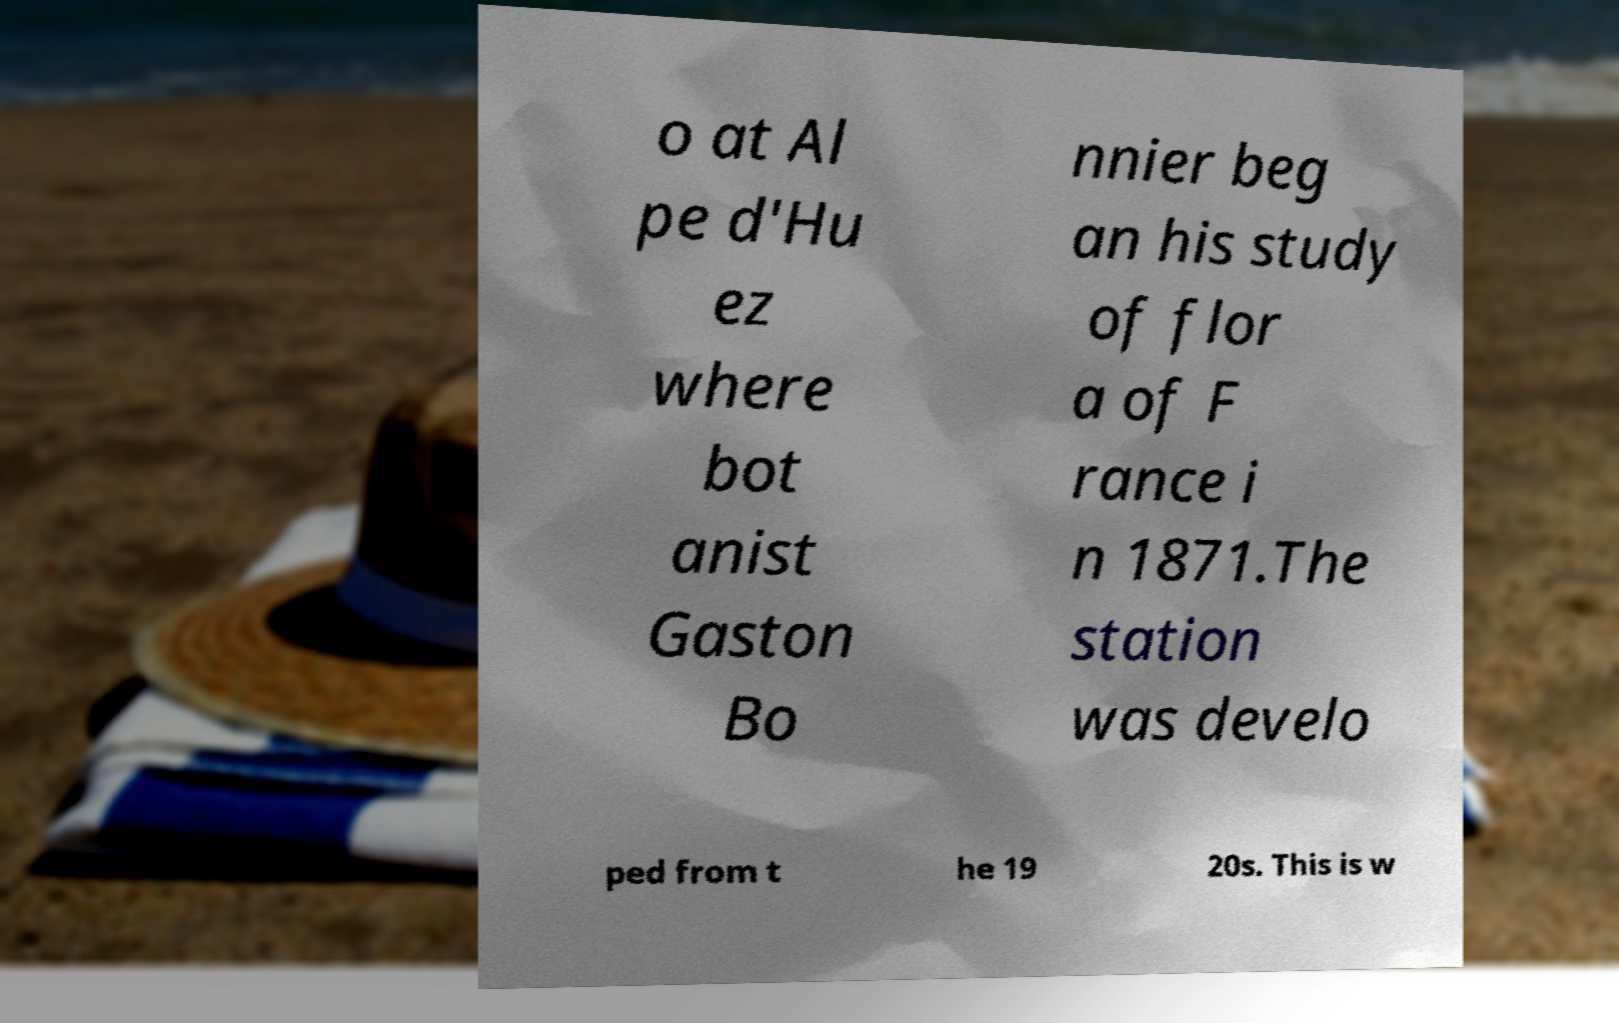Please read and relay the text visible in this image. What does it say? o at Al pe d'Hu ez where bot anist Gaston Bo nnier beg an his study of flor a of F rance i n 1871.The station was develo ped from t he 19 20s. This is w 